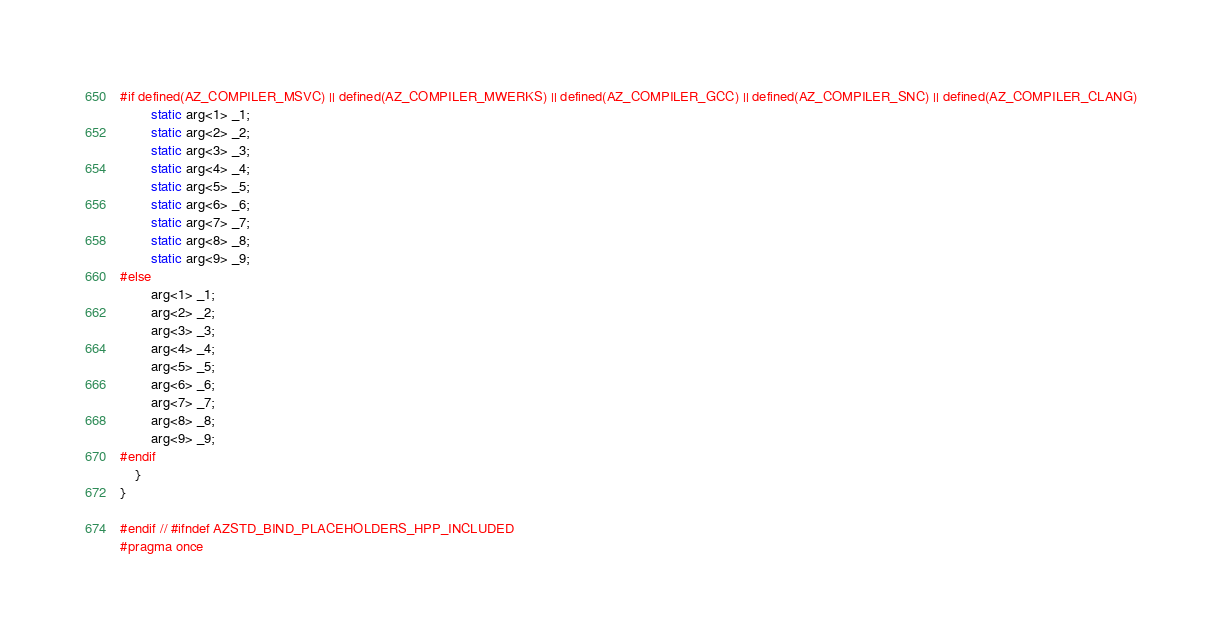<code> <loc_0><loc_0><loc_500><loc_500><_C_>#if defined(AZ_COMPILER_MSVC) || defined(AZ_COMPILER_MWERKS) || defined(AZ_COMPILER_GCC) || defined(AZ_COMPILER_SNC) || defined(AZ_COMPILER_CLANG)
        static arg<1> _1;
        static arg<2> _2;
        static arg<3> _3;
        static arg<4> _4;
        static arg<5> _5;
        static arg<6> _6;
        static arg<7> _7;
        static arg<8> _8;
        static arg<9> _9;
#else
        arg<1> _1;
        arg<2> _2;
        arg<3> _3;
        arg<4> _4;
        arg<5> _5;
        arg<6> _6;
        arg<7> _7;
        arg<8> _8;
        arg<9> _9;
#endif
    }
}

#endif // #ifndef AZSTD_BIND_PLACEHOLDERS_HPP_INCLUDED
#pragma once
</code> 